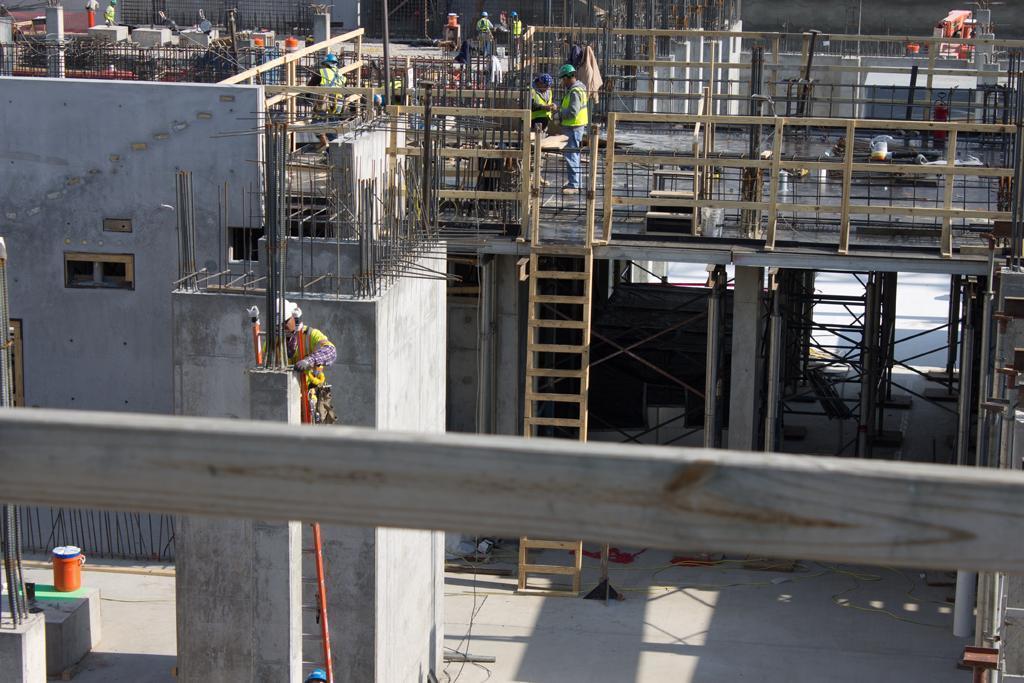Could you give a brief overview of what you see in this image? In this picture I can see a building and I can see number of rods. I can also see few people. In the middle of this picture I can see a ladder. On the left side of this image I can see an orange color thing. 